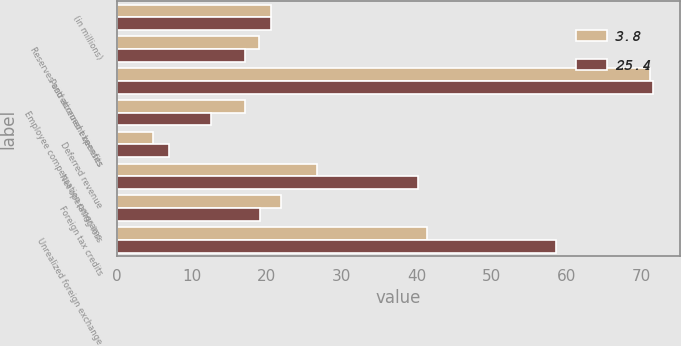Convert chart to OTSL. <chart><loc_0><loc_0><loc_500><loc_500><stacked_bar_chart><ecel><fcel>(in millions)<fcel>Reserves and accrued expenses<fcel>Postretirement benefits<fcel>Employee compensation programs<fcel>Deferred revenue<fcel>Net operating loss<fcel>Foreign tax credits<fcel>Unrealized foreign exchange<nl><fcel>3.8<fcel>20.5<fcel>18.9<fcel>71.1<fcel>17.1<fcel>4.8<fcel>26.7<fcel>21.9<fcel>41.4<nl><fcel>25.4<fcel>20.5<fcel>17.1<fcel>71.5<fcel>12.6<fcel>7<fcel>40.1<fcel>19.1<fcel>58.5<nl></chart> 